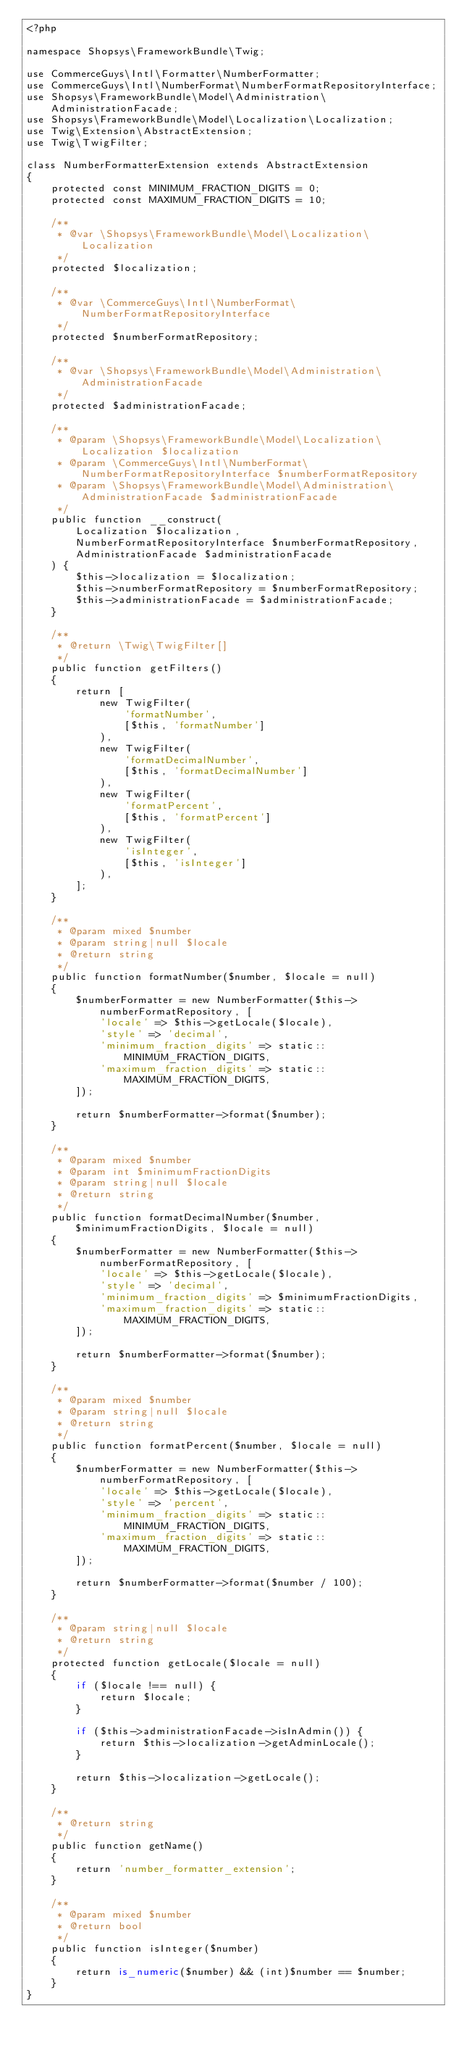<code> <loc_0><loc_0><loc_500><loc_500><_PHP_><?php

namespace Shopsys\FrameworkBundle\Twig;

use CommerceGuys\Intl\Formatter\NumberFormatter;
use CommerceGuys\Intl\NumberFormat\NumberFormatRepositoryInterface;
use Shopsys\FrameworkBundle\Model\Administration\AdministrationFacade;
use Shopsys\FrameworkBundle\Model\Localization\Localization;
use Twig\Extension\AbstractExtension;
use Twig\TwigFilter;

class NumberFormatterExtension extends AbstractExtension
{
    protected const MINIMUM_FRACTION_DIGITS = 0;
    protected const MAXIMUM_FRACTION_DIGITS = 10;

    /**
     * @var \Shopsys\FrameworkBundle\Model\Localization\Localization
     */
    protected $localization;

    /**
     * @var \CommerceGuys\Intl\NumberFormat\NumberFormatRepositoryInterface
     */
    protected $numberFormatRepository;

    /**
     * @var \Shopsys\FrameworkBundle\Model\Administration\AdministrationFacade
     */
    protected $administrationFacade;

    /**
     * @param \Shopsys\FrameworkBundle\Model\Localization\Localization $localization
     * @param \CommerceGuys\Intl\NumberFormat\NumberFormatRepositoryInterface $numberFormatRepository
     * @param \Shopsys\FrameworkBundle\Model\Administration\AdministrationFacade $administrationFacade
     */
    public function __construct(
        Localization $localization,
        NumberFormatRepositoryInterface $numberFormatRepository,
        AdministrationFacade $administrationFacade
    ) {
        $this->localization = $localization;
        $this->numberFormatRepository = $numberFormatRepository;
        $this->administrationFacade = $administrationFacade;
    }

    /**
     * @return \Twig\TwigFilter[]
     */
    public function getFilters()
    {
        return [
            new TwigFilter(
                'formatNumber',
                [$this, 'formatNumber']
            ),
            new TwigFilter(
                'formatDecimalNumber',
                [$this, 'formatDecimalNumber']
            ),
            new TwigFilter(
                'formatPercent',
                [$this, 'formatPercent']
            ),
            new TwigFilter(
                'isInteger',
                [$this, 'isInteger']
            ),
        ];
    }

    /**
     * @param mixed $number
     * @param string|null $locale
     * @return string
     */
    public function formatNumber($number, $locale = null)
    {
        $numberFormatter = new NumberFormatter($this->numberFormatRepository, [
            'locale' => $this->getLocale($locale),
            'style' => 'decimal',
            'minimum_fraction_digits' => static::MINIMUM_FRACTION_DIGITS,
            'maximum_fraction_digits' => static::MAXIMUM_FRACTION_DIGITS,
        ]);

        return $numberFormatter->format($number);
    }

    /**
     * @param mixed $number
     * @param int $minimumFractionDigits
     * @param string|null $locale
     * @return string
     */
    public function formatDecimalNumber($number, $minimumFractionDigits, $locale = null)
    {
        $numberFormatter = new NumberFormatter($this->numberFormatRepository, [
            'locale' => $this->getLocale($locale),
            'style' => 'decimal',
            'minimum_fraction_digits' => $minimumFractionDigits,
            'maximum_fraction_digits' => static::MAXIMUM_FRACTION_DIGITS,
        ]);

        return $numberFormatter->format($number);
    }

    /**
     * @param mixed $number
     * @param string|null $locale
     * @return string
     */
    public function formatPercent($number, $locale = null)
    {
        $numberFormatter = new NumberFormatter($this->numberFormatRepository, [
            'locale' => $this->getLocale($locale),
            'style' => 'percent',
            'minimum_fraction_digits' => static::MINIMUM_FRACTION_DIGITS,
            'maximum_fraction_digits' => static::MAXIMUM_FRACTION_DIGITS,
        ]);

        return $numberFormatter->format($number / 100);
    }

    /**
     * @param string|null $locale
     * @return string
     */
    protected function getLocale($locale = null)
    {
        if ($locale !== null) {
            return $locale;
        }

        if ($this->administrationFacade->isInAdmin()) {
            return $this->localization->getAdminLocale();
        }

        return $this->localization->getLocale();
    }

    /**
     * @return string
     */
    public function getName()
    {
        return 'number_formatter_extension';
    }

    /**
     * @param mixed $number
     * @return bool
     */
    public function isInteger($number)
    {
        return is_numeric($number) && (int)$number == $number;
    }
}
</code> 